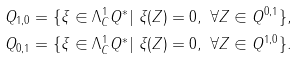<formula> <loc_0><loc_0><loc_500><loc_500>Q _ { 1 , 0 } & = \{ \xi \in \Lambda ^ { 1 } _ { C } Q ^ { * } | \ \xi ( Z ) = 0 , \ \forall Z \in Q ^ { 0 , 1 } \} , \\ Q _ { 0 , 1 } & = \{ \xi \in \Lambda ^ { 1 } _ { C } Q ^ { * } | \ \xi ( Z ) = 0 , \ \forall Z \in Q ^ { 1 , 0 } \} .</formula> 